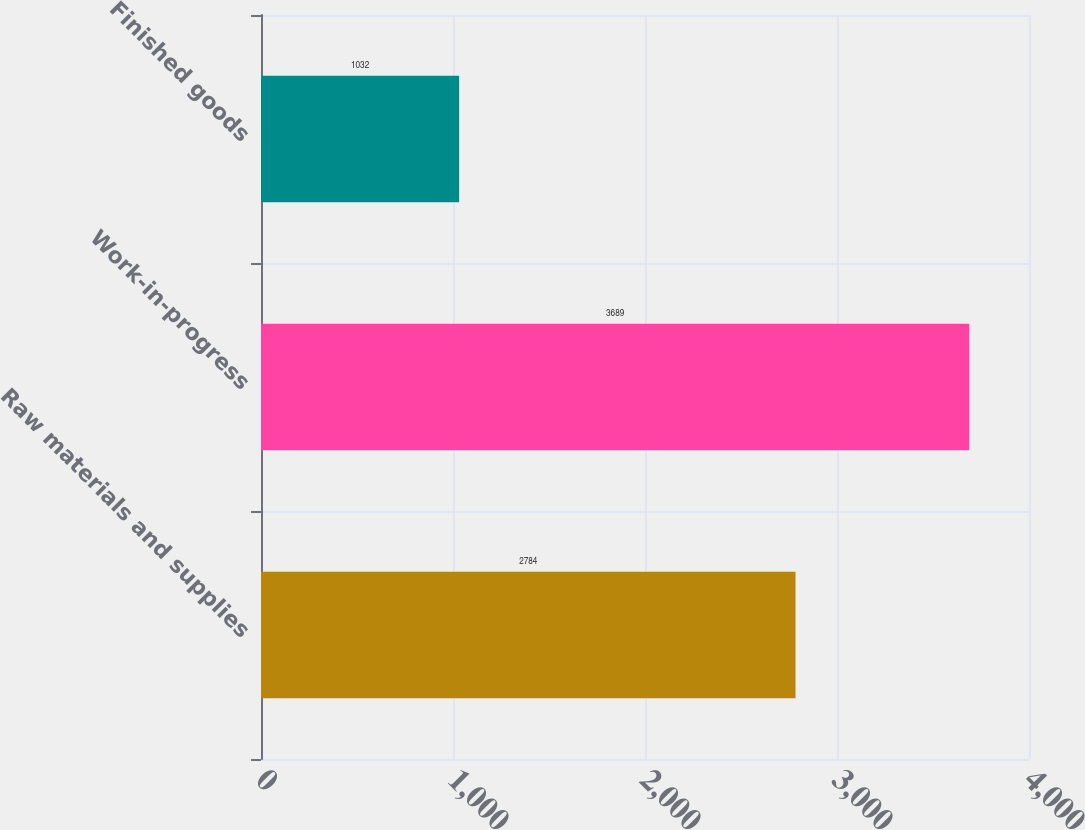Convert chart to OTSL. <chart><loc_0><loc_0><loc_500><loc_500><bar_chart><fcel>Raw materials and supplies<fcel>Work-in-progress<fcel>Finished goods<nl><fcel>2784<fcel>3689<fcel>1032<nl></chart> 